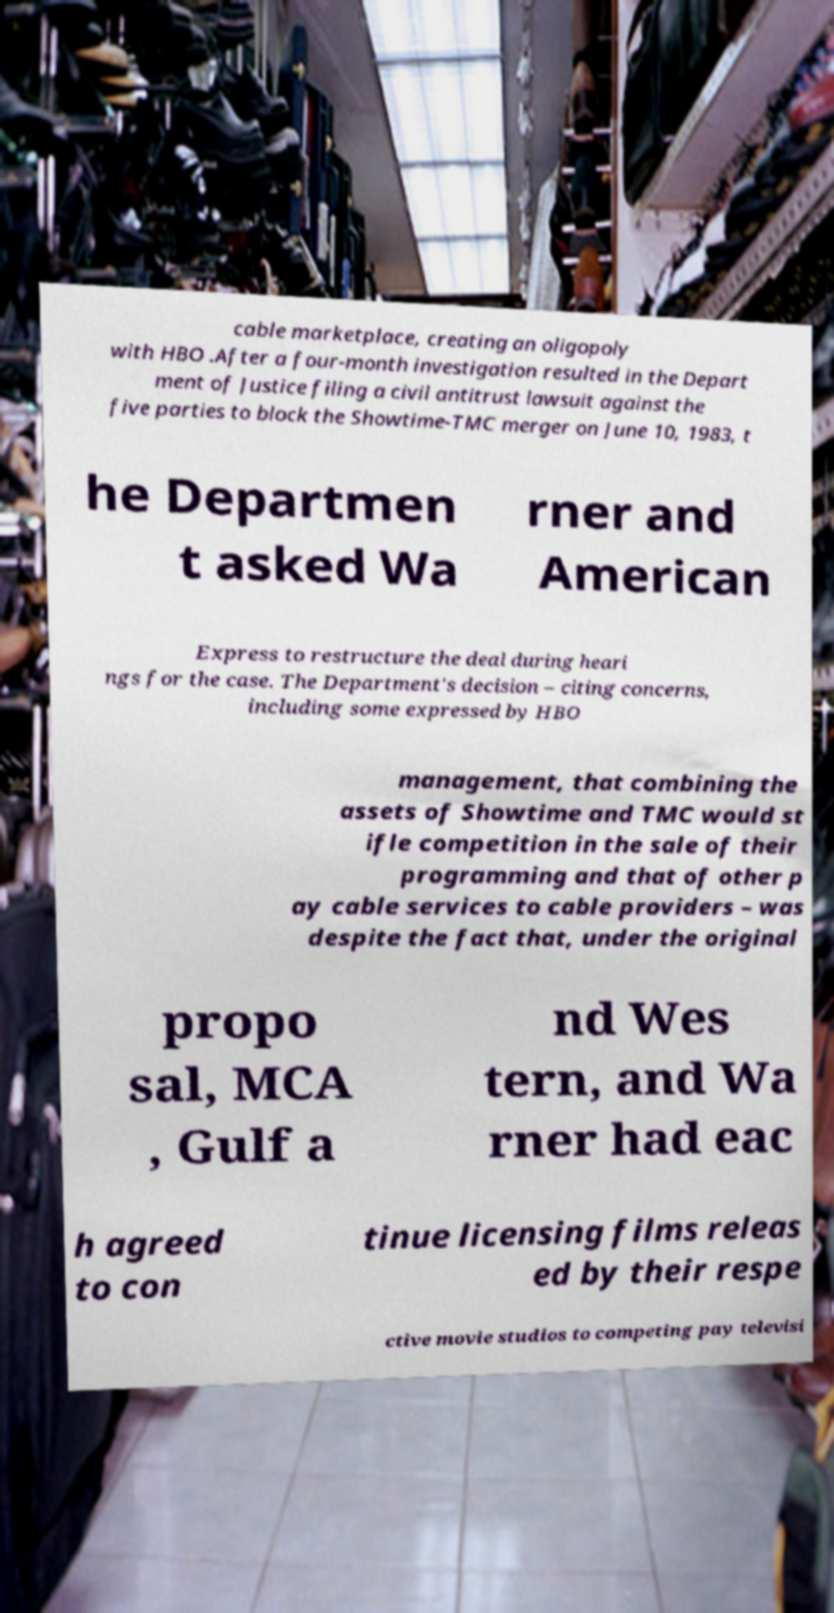What messages or text are displayed in this image? I need them in a readable, typed format. cable marketplace, creating an oligopoly with HBO .After a four-month investigation resulted in the Depart ment of Justice filing a civil antitrust lawsuit against the five parties to block the Showtime-TMC merger on June 10, 1983, t he Departmen t asked Wa rner and American Express to restructure the deal during heari ngs for the case. The Department's decision – citing concerns, including some expressed by HBO management, that combining the assets of Showtime and TMC would st ifle competition in the sale of their programming and that of other p ay cable services to cable providers – was despite the fact that, under the original propo sal, MCA , Gulf a nd Wes tern, and Wa rner had eac h agreed to con tinue licensing films releas ed by their respe ctive movie studios to competing pay televisi 